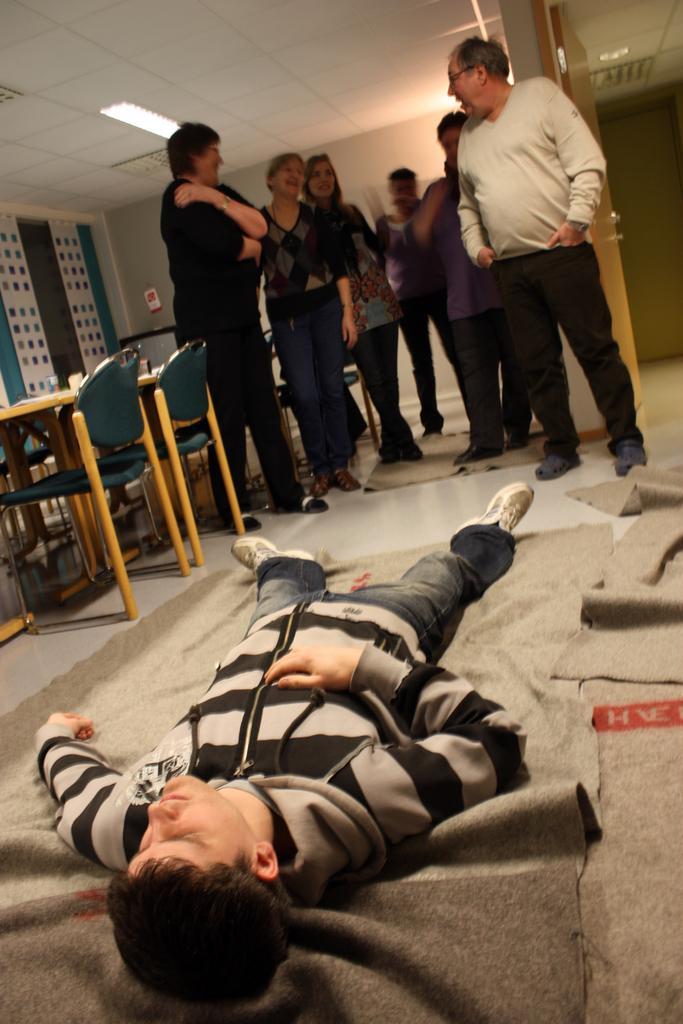Can you describe this image briefly? This picture describes about group of people one person is lying on the floor and we can see couple of chairs and tables, and also we can find couple of lights. 